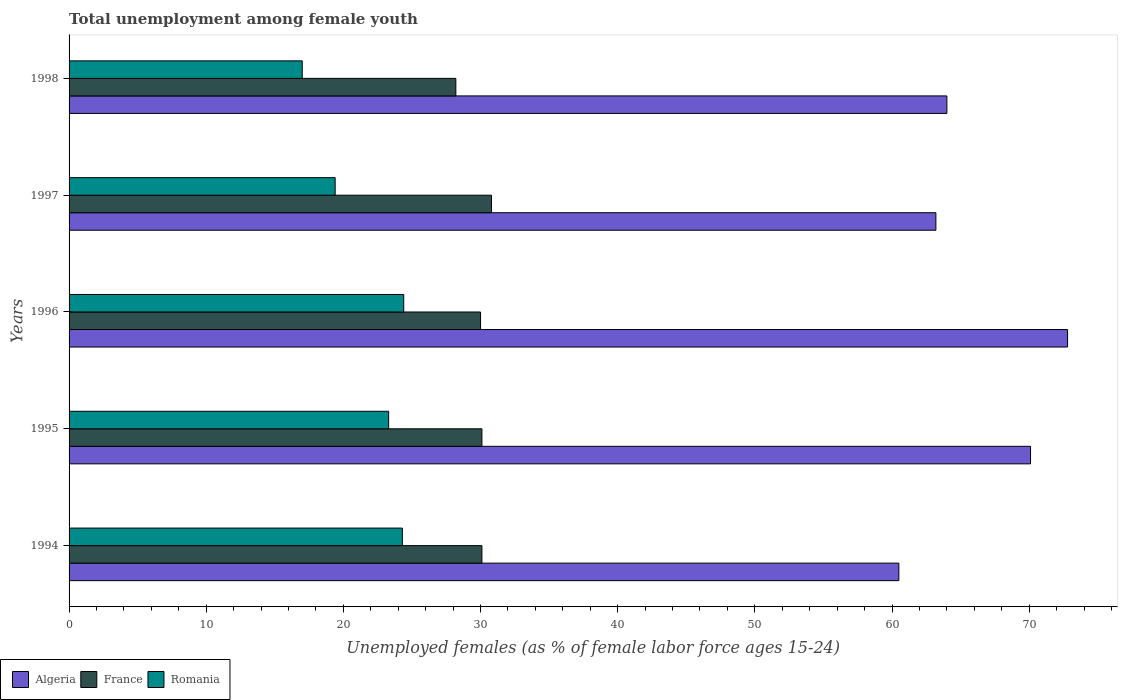How many different coloured bars are there?
Your answer should be very brief. 3. Are the number of bars on each tick of the Y-axis equal?
Make the answer very short. Yes. How many bars are there on the 5th tick from the top?
Provide a succinct answer. 3. How many bars are there on the 2nd tick from the bottom?
Provide a succinct answer. 3. What is the label of the 2nd group of bars from the top?
Keep it short and to the point. 1997. What is the percentage of unemployed females in in Algeria in 1995?
Ensure brevity in your answer.  70.1. Across all years, what is the maximum percentage of unemployed females in in France?
Provide a short and direct response. 30.8. Across all years, what is the minimum percentage of unemployed females in in Romania?
Your answer should be compact. 17. In which year was the percentage of unemployed females in in Algeria minimum?
Your answer should be compact. 1994. What is the total percentage of unemployed females in in Algeria in the graph?
Your answer should be very brief. 330.6. What is the difference between the percentage of unemployed females in in Algeria in 1995 and that in 1996?
Your response must be concise. -2.7. What is the difference between the percentage of unemployed females in in Romania in 1996 and the percentage of unemployed females in in Algeria in 1995?
Provide a short and direct response. -45.7. What is the average percentage of unemployed females in in France per year?
Ensure brevity in your answer.  29.84. In the year 1994, what is the difference between the percentage of unemployed females in in Romania and percentage of unemployed females in in France?
Give a very brief answer. -5.8. What is the ratio of the percentage of unemployed females in in Romania in 1994 to that in 1998?
Your answer should be compact. 1.43. Is the percentage of unemployed females in in Romania in 1994 less than that in 1998?
Your answer should be compact. No. Is the difference between the percentage of unemployed females in in Romania in 1997 and 1998 greater than the difference between the percentage of unemployed females in in France in 1997 and 1998?
Offer a terse response. No. What is the difference between the highest and the second highest percentage of unemployed females in in Algeria?
Give a very brief answer. 2.7. What is the difference between the highest and the lowest percentage of unemployed females in in Romania?
Ensure brevity in your answer.  7.4. In how many years, is the percentage of unemployed females in in Romania greater than the average percentage of unemployed females in in Romania taken over all years?
Provide a succinct answer. 3. Is the sum of the percentage of unemployed females in in France in 1995 and 1997 greater than the maximum percentage of unemployed females in in Algeria across all years?
Offer a terse response. No. What does the 1st bar from the top in 1997 represents?
Your answer should be compact. Romania. What does the 2nd bar from the bottom in 1998 represents?
Provide a succinct answer. France. Are all the bars in the graph horizontal?
Offer a very short reply. Yes. What is the difference between two consecutive major ticks on the X-axis?
Your answer should be very brief. 10. Are the values on the major ticks of X-axis written in scientific E-notation?
Keep it short and to the point. No. Does the graph contain grids?
Your answer should be compact. No. Where does the legend appear in the graph?
Your answer should be compact. Bottom left. How are the legend labels stacked?
Your answer should be very brief. Horizontal. What is the title of the graph?
Ensure brevity in your answer.  Total unemployment among female youth. Does "Dominican Republic" appear as one of the legend labels in the graph?
Give a very brief answer. No. What is the label or title of the X-axis?
Make the answer very short. Unemployed females (as % of female labor force ages 15-24). What is the label or title of the Y-axis?
Provide a succinct answer. Years. What is the Unemployed females (as % of female labor force ages 15-24) of Algeria in 1994?
Give a very brief answer. 60.5. What is the Unemployed females (as % of female labor force ages 15-24) of France in 1994?
Offer a terse response. 30.1. What is the Unemployed females (as % of female labor force ages 15-24) in Romania in 1994?
Give a very brief answer. 24.3. What is the Unemployed females (as % of female labor force ages 15-24) of Algeria in 1995?
Ensure brevity in your answer.  70.1. What is the Unemployed females (as % of female labor force ages 15-24) in France in 1995?
Keep it short and to the point. 30.1. What is the Unemployed females (as % of female labor force ages 15-24) in Romania in 1995?
Your answer should be very brief. 23.3. What is the Unemployed females (as % of female labor force ages 15-24) in Algeria in 1996?
Provide a succinct answer. 72.8. What is the Unemployed females (as % of female labor force ages 15-24) in France in 1996?
Provide a short and direct response. 30. What is the Unemployed females (as % of female labor force ages 15-24) of Romania in 1996?
Give a very brief answer. 24.4. What is the Unemployed females (as % of female labor force ages 15-24) in Algeria in 1997?
Provide a succinct answer. 63.2. What is the Unemployed females (as % of female labor force ages 15-24) of France in 1997?
Offer a very short reply. 30.8. What is the Unemployed females (as % of female labor force ages 15-24) of Romania in 1997?
Make the answer very short. 19.4. What is the Unemployed females (as % of female labor force ages 15-24) of France in 1998?
Provide a succinct answer. 28.2. Across all years, what is the maximum Unemployed females (as % of female labor force ages 15-24) in Algeria?
Make the answer very short. 72.8. Across all years, what is the maximum Unemployed females (as % of female labor force ages 15-24) of France?
Your answer should be compact. 30.8. Across all years, what is the maximum Unemployed females (as % of female labor force ages 15-24) of Romania?
Offer a very short reply. 24.4. Across all years, what is the minimum Unemployed females (as % of female labor force ages 15-24) in Algeria?
Make the answer very short. 60.5. Across all years, what is the minimum Unemployed females (as % of female labor force ages 15-24) of France?
Offer a terse response. 28.2. What is the total Unemployed females (as % of female labor force ages 15-24) of Algeria in the graph?
Offer a very short reply. 330.6. What is the total Unemployed females (as % of female labor force ages 15-24) of France in the graph?
Give a very brief answer. 149.2. What is the total Unemployed females (as % of female labor force ages 15-24) in Romania in the graph?
Give a very brief answer. 108.4. What is the difference between the Unemployed females (as % of female labor force ages 15-24) in Algeria in 1994 and that in 1995?
Keep it short and to the point. -9.6. What is the difference between the Unemployed females (as % of female labor force ages 15-24) in France in 1994 and that in 1995?
Your response must be concise. 0. What is the difference between the Unemployed females (as % of female labor force ages 15-24) in Romania in 1994 and that in 1995?
Keep it short and to the point. 1. What is the difference between the Unemployed females (as % of female labor force ages 15-24) of Algeria in 1994 and that in 1997?
Provide a short and direct response. -2.7. What is the difference between the Unemployed females (as % of female labor force ages 15-24) in Romania in 1994 and that in 1997?
Keep it short and to the point. 4.9. What is the difference between the Unemployed females (as % of female labor force ages 15-24) in Algeria in 1994 and that in 1998?
Provide a short and direct response. -3.5. What is the difference between the Unemployed females (as % of female labor force ages 15-24) in France in 1994 and that in 1998?
Give a very brief answer. 1.9. What is the difference between the Unemployed females (as % of female labor force ages 15-24) of Romania in 1994 and that in 1998?
Keep it short and to the point. 7.3. What is the difference between the Unemployed females (as % of female labor force ages 15-24) in Algeria in 1995 and that in 1996?
Provide a succinct answer. -2.7. What is the difference between the Unemployed females (as % of female labor force ages 15-24) in Romania in 1995 and that in 1996?
Make the answer very short. -1.1. What is the difference between the Unemployed females (as % of female labor force ages 15-24) of Algeria in 1995 and that in 1997?
Provide a succinct answer. 6.9. What is the difference between the Unemployed females (as % of female labor force ages 15-24) of France in 1995 and that in 1997?
Your answer should be very brief. -0.7. What is the difference between the Unemployed females (as % of female labor force ages 15-24) of Romania in 1995 and that in 1997?
Offer a terse response. 3.9. What is the difference between the Unemployed females (as % of female labor force ages 15-24) in Romania in 1995 and that in 1998?
Ensure brevity in your answer.  6.3. What is the difference between the Unemployed females (as % of female labor force ages 15-24) of Algeria in 1996 and that in 1997?
Provide a short and direct response. 9.6. What is the difference between the Unemployed females (as % of female labor force ages 15-24) in France in 1996 and that in 1997?
Make the answer very short. -0.8. What is the difference between the Unemployed females (as % of female labor force ages 15-24) in Algeria in 1996 and that in 1998?
Provide a succinct answer. 8.8. What is the difference between the Unemployed females (as % of female labor force ages 15-24) in Romania in 1997 and that in 1998?
Ensure brevity in your answer.  2.4. What is the difference between the Unemployed females (as % of female labor force ages 15-24) of Algeria in 1994 and the Unemployed females (as % of female labor force ages 15-24) of France in 1995?
Keep it short and to the point. 30.4. What is the difference between the Unemployed females (as % of female labor force ages 15-24) in Algeria in 1994 and the Unemployed females (as % of female labor force ages 15-24) in Romania in 1995?
Offer a terse response. 37.2. What is the difference between the Unemployed females (as % of female labor force ages 15-24) in France in 1994 and the Unemployed females (as % of female labor force ages 15-24) in Romania in 1995?
Provide a short and direct response. 6.8. What is the difference between the Unemployed females (as % of female labor force ages 15-24) in Algeria in 1994 and the Unemployed females (as % of female labor force ages 15-24) in France in 1996?
Keep it short and to the point. 30.5. What is the difference between the Unemployed females (as % of female labor force ages 15-24) of Algeria in 1994 and the Unemployed females (as % of female labor force ages 15-24) of Romania in 1996?
Provide a short and direct response. 36.1. What is the difference between the Unemployed females (as % of female labor force ages 15-24) of Algeria in 1994 and the Unemployed females (as % of female labor force ages 15-24) of France in 1997?
Your answer should be very brief. 29.7. What is the difference between the Unemployed females (as % of female labor force ages 15-24) in Algeria in 1994 and the Unemployed females (as % of female labor force ages 15-24) in Romania in 1997?
Ensure brevity in your answer.  41.1. What is the difference between the Unemployed females (as % of female labor force ages 15-24) in Algeria in 1994 and the Unemployed females (as % of female labor force ages 15-24) in France in 1998?
Keep it short and to the point. 32.3. What is the difference between the Unemployed females (as % of female labor force ages 15-24) in Algeria in 1994 and the Unemployed females (as % of female labor force ages 15-24) in Romania in 1998?
Provide a succinct answer. 43.5. What is the difference between the Unemployed females (as % of female labor force ages 15-24) of Algeria in 1995 and the Unemployed females (as % of female labor force ages 15-24) of France in 1996?
Give a very brief answer. 40.1. What is the difference between the Unemployed females (as % of female labor force ages 15-24) of Algeria in 1995 and the Unemployed females (as % of female labor force ages 15-24) of Romania in 1996?
Your response must be concise. 45.7. What is the difference between the Unemployed females (as % of female labor force ages 15-24) in Algeria in 1995 and the Unemployed females (as % of female labor force ages 15-24) in France in 1997?
Provide a succinct answer. 39.3. What is the difference between the Unemployed females (as % of female labor force ages 15-24) of Algeria in 1995 and the Unemployed females (as % of female labor force ages 15-24) of Romania in 1997?
Offer a terse response. 50.7. What is the difference between the Unemployed females (as % of female labor force ages 15-24) in Algeria in 1995 and the Unemployed females (as % of female labor force ages 15-24) in France in 1998?
Keep it short and to the point. 41.9. What is the difference between the Unemployed females (as % of female labor force ages 15-24) in Algeria in 1995 and the Unemployed females (as % of female labor force ages 15-24) in Romania in 1998?
Offer a very short reply. 53.1. What is the difference between the Unemployed females (as % of female labor force ages 15-24) in France in 1995 and the Unemployed females (as % of female labor force ages 15-24) in Romania in 1998?
Ensure brevity in your answer.  13.1. What is the difference between the Unemployed females (as % of female labor force ages 15-24) of Algeria in 1996 and the Unemployed females (as % of female labor force ages 15-24) of Romania in 1997?
Give a very brief answer. 53.4. What is the difference between the Unemployed females (as % of female labor force ages 15-24) in Algeria in 1996 and the Unemployed females (as % of female labor force ages 15-24) in France in 1998?
Give a very brief answer. 44.6. What is the difference between the Unemployed females (as % of female labor force ages 15-24) in Algeria in 1996 and the Unemployed females (as % of female labor force ages 15-24) in Romania in 1998?
Your answer should be very brief. 55.8. What is the difference between the Unemployed females (as % of female labor force ages 15-24) in France in 1996 and the Unemployed females (as % of female labor force ages 15-24) in Romania in 1998?
Offer a very short reply. 13. What is the difference between the Unemployed females (as % of female labor force ages 15-24) in Algeria in 1997 and the Unemployed females (as % of female labor force ages 15-24) in Romania in 1998?
Give a very brief answer. 46.2. What is the average Unemployed females (as % of female labor force ages 15-24) in Algeria per year?
Provide a short and direct response. 66.12. What is the average Unemployed females (as % of female labor force ages 15-24) of France per year?
Your answer should be very brief. 29.84. What is the average Unemployed females (as % of female labor force ages 15-24) of Romania per year?
Your answer should be very brief. 21.68. In the year 1994, what is the difference between the Unemployed females (as % of female labor force ages 15-24) in Algeria and Unemployed females (as % of female labor force ages 15-24) in France?
Give a very brief answer. 30.4. In the year 1994, what is the difference between the Unemployed females (as % of female labor force ages 15-24) in Algeria and Unemployed females (as % of female labor force ages 15-24) in Romania?
Ensure brevity in your answer.  36.2. In the year 1995, what is the difference between the Unemployed females (as % of female labor force ages 15-24) of Algeria and Unemployed females (as % of female labor force ages 15-24) of France?
Your answer should be very brief. 40. In the year 1995, what is the difference between the Unemployed females (as % of female labor force ages 15-24) of Algeria and Unemployed females (as % of female labor force ages 15-24) of Romania?
Provide a succinct answer. 46.8. In the year 1996, what is the difference between the Unemployed females (as % of female labor force ages 15-24) of Algeria and Unemployed females (as % of female labor force ages 15-24) of France?
Provide a succinct answer. 42.8. In the year 1996, what is the difference between the Unemployed females (as % of female labor force ages 15-24) in Algeria and Unemployed females (as % of female labor force ages 15-24) in Romania?
Your response must be concise. 48.4. In the year 1997, what is the difference between the Unemployed females (as % of female labor force ages 15-24) in Algeria and Unemployed females (as % of female labor force ages 15-24) in France?
Provide a short and direct response. 32.4. In the year 1997, what is the difference between the Unemployed females (as % of female labor force ages 15-24) of Algeria and Unemployed females (as % of female labor force ages 15-24) of Romania?
Keep it short and to the point. 43.8. In the year 1998, what is the difference between the Unemployed females (as % of female labor force ages 15-24) of Algeria and Unemployed females (as % of female labor force ages 15-24) of France?
Offer a terse response. 35.8. In the year 1998, what is the difference between the Unemployed females (as % of female labor force ages 15-24) in France and Unemployed females (as % of female labor force ages 15-24) in Romania?
Ensure brevity in your answer.  11.2. What is the ratio of the Unemployed females (as % of female labor force ages 15-24) in Algeria in 1994 to that in 1995?
Give a very brief answer. 0.86. What is the ratio of the Unemployed females (as % of female labor force ages 15-24) in Romania in 1994 to that in 1995?
Ensure brevity in your answer.  1.04. What is the ratio of the Unemployed females (as % of female labor force ages 15-24) of Algeria in 1994 to that in 1996?
Your answer should be very brief. 0.83. What is the ratio of the Unemployed females (as % of female labor force ages 15-24) of Romania in 1994 to that in 1996?
Make the answer very short. 1. What is the ratio of the Unemployed females (as % of female labor force ages 15-24) of Algeria in 1994 to that in 1997?
Keep it short and to the point. 0.96. What is the ratio of the Unemployed females (as % of female labor force ages 15-24) of France in 1994 to that in 1997?
Offer a terse response. 0.98. What is the ratio of the Unemployed females (as % of female labor force ages 15-24) in Romania in 1994 to that in 1997?
Offer a terse response. 1.25. What is the ratio of the Unemployed females (as % of female labor force ages 15-24) of Algeria in 1994 to that in 1998?
Give a very brief answer. 0.95. What is the ratio of the Unemployed females (as % of female labor force ages 15-24) of France in 1994 to that in 1998?
Offer a very short reply. 1.07. What is the ratio of the Unemployed females (as % of female labor force ages 15-24) in Romania in 1994 to that in 1998?
Offer a terse response. 1.43. What is the ratio of the Unemployed females (as % of female labor force ages 15-24) in Algeria in 1995 to that in 1996?
Ensure brevity in your answer.  0.96. What is the ratio of the Unemployed females (as % of female labor force ages 15-24) of Romania in 1995 to that in 1996?
Keep it short and to the point. 0.95. What is the ratio of the Unemployed females (as % of female labor force ages 15-24) in Algeria in 1995 to that in 1997?
Your answer should be very brief. 1.11. What is the ratio of the Unemployed females (as % of female labor force ages 15-24) in France in 1995 to that in 1997?
Make the answer very short. 0.98. What is the ratio of the Unemployed females (as % of female labor force ages 15-24) of Romania in 1995 to that in 1997?
Provide a short and direct response. 1.2. What is the ratio of the Unemployed females (as % of female labor force ages 15-24) in Algeria in 1995 to that in 1998?
Your answer should be compact. 1.1. What is the ratio of the Unemployed females (as % of female labor force ages 15-24) of France in 1995 to that in 1998?
Make the answer very short. 1.07. What is the ratio of the Unemployed females (as % of female labor force ages 15-24) in Romania in 1995 to that in 1998?
Provide a succinct answer. 1.37. What is the ratio of the Unemployed females (as % of female labor force ages 15-24) in Algeria in 1996 to that in 1997?
Provide a short and direct response. 1.15. What is the ratio of the Unemployed females (as % of female labor force ages 15-24) of Romania in 1996 to that in 1997?
Your answer should be compact. 1.26. What is the ratio of the Unemployed females (as % of female labor force ages 15-24) in Algeria in 1996 to that in 1998?
Your response must be concise. 1.14. What is the ratio of the Unemployed females (as % of female labor force ages 15-24) in France in 1996 to that in 1998?
Offer a very short reply. 1.06. What is the ratio of the Unemployed females (as % of female labor force ages 15-24) of Romania in 1996 to that in 1998?
Make the answer very short. 1.44. What is the ratio of the Unemployed females (as % of female labor force ages 15-24) of Algeria in 1997 to that in 1998?
Ensure brevity in your answer.  0.99. What is the ratio of the Unemployed females (as % of female labor force ages 15-24) of France in 1997 to that in 1998?
Offer a terse response. 1.09. What is the ratio of the Unemployed females (as % of female labor force ages 15-24) in Romania in 1997 to that in 1998?
Offer a very short reply. 1.14. What is the difference between the highest and the lowest Unemployed females (as % of female labor force ages 15-24) in Romania?
Offer a terse response. 7.4. 